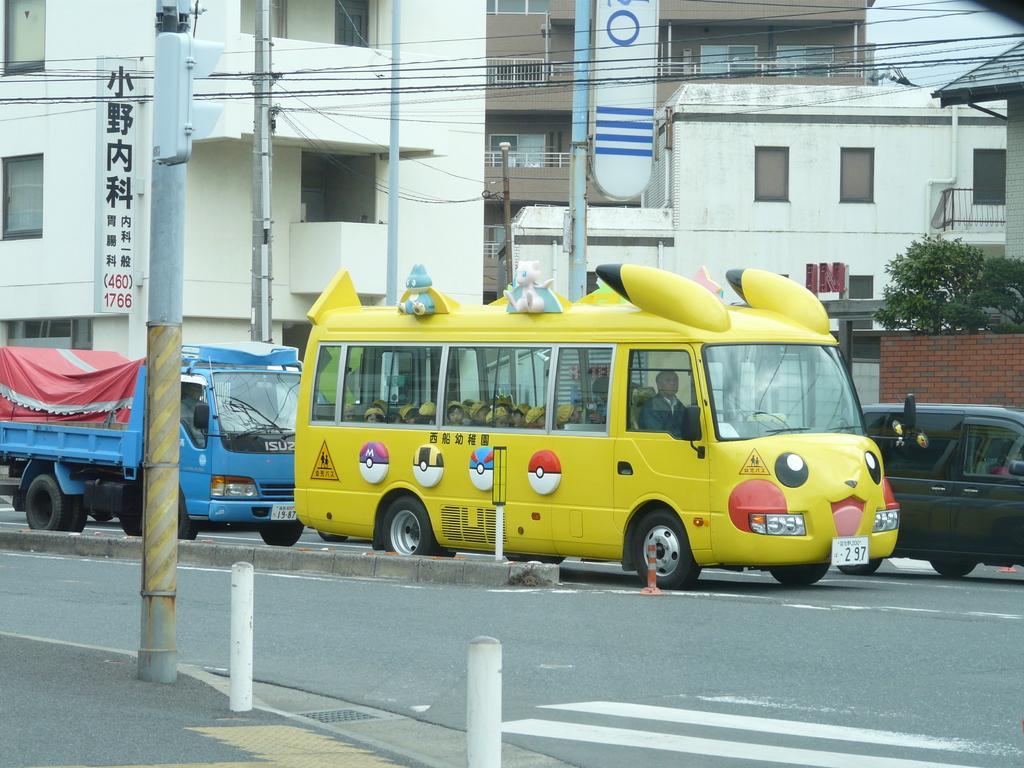Please provide a concise description of this image. In this image we can see many buildings, some text board attached to one building. Two trees are near to the wall. Three safety poles and four poles are there. One car is on the road, one vehicle is back to the school bus. In school bus one driver so many children are there. Some wires are there. 